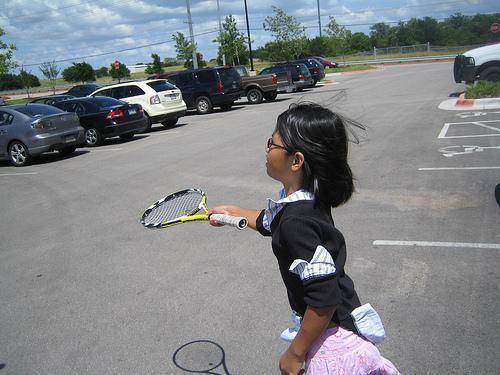How many people are in the photo?
Give a very brief answer. 1. 